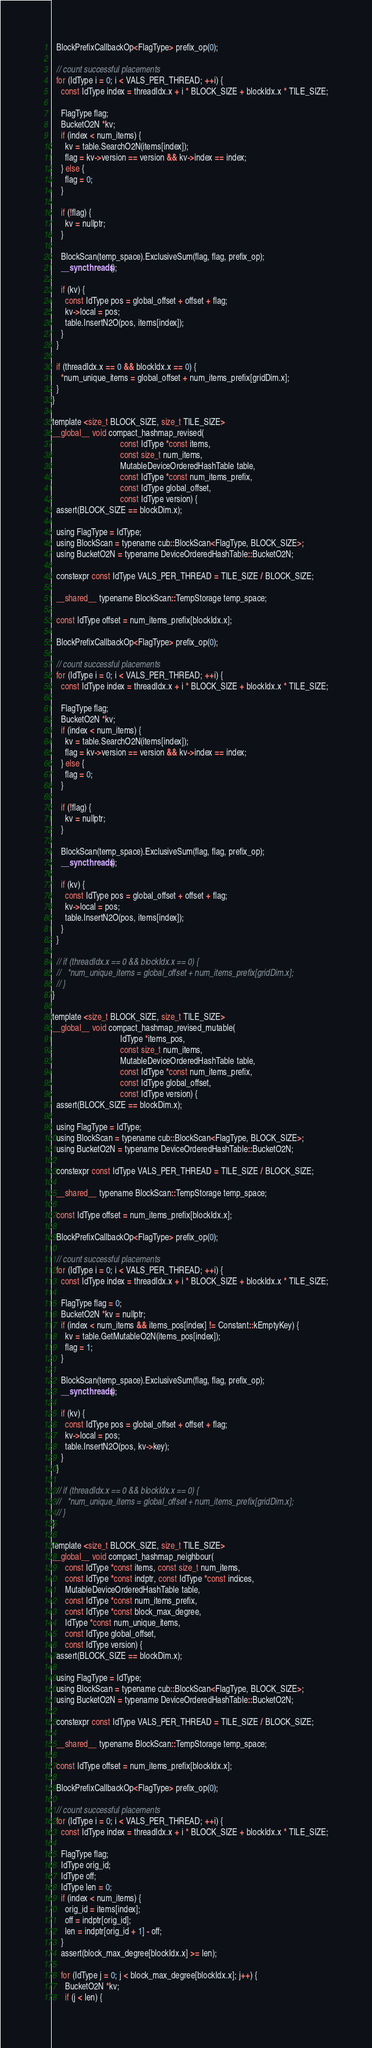<code> <loc_0><loc_0><loc_500><loc_500><_Cuda_>
  BlockPrefixCallbackOp<FlagType> prefix_op(0);

  // count successful placements
  for (IdType i = 0; i < VALS_PER_THREAD; ++i) {
    const IdType index = threadIdx.x + i * BLOCK_SIZE + blockIdx.x * TILE_SIZE;

    FlagType flag;
    BucketO2N *kv;
    if (index < num_items) {
      kv = table.SearchO2N(items[index]);
      flag = kv->version == version && kv->index == index;
    } else {
      flag = 0;
    }

    if (!flag) {
      kv = nullptr;
    }

    BlockScan(temp_space).ExclusiveSum(flag, flag, prefix_op);
    __syncthreads();

    if (kv) {
      const IdType pos = global_offset + offset + flag;
      kv->local = pos;
      table.InsertN2O(pos, items[index]);
    }
  }

  if (threadIdx.x == 0 && blockIdx.x == 0) {
    *num_unique_items = global_offset + num_items_prefix[gridDim.x];
  }
}

template <size_t BLOCK_SIZE, size_t TILE_SIZE>
__global__ void compact_hashmap_revised(
                                const IdType *const items,
                                const size_t num_items,
                                MutableDeviceOrderedHashTable table,
                                const IdType *const num_items_prefix,
                                const IdType global_offset,
                                const IdType version) {
  assert(BLOCK_SIZE == blockDim.x);

  using FlagType = IdType;
  using BlockScan = typename cub::BlockScan<FlagType, BLOCK_SIZE>;
  using BucketO2N = typename DeviceOrderedHashTable::BucketO2N;

  constexpr const IdType VALS_PER_THREAD = TILE_SIZE / BLOCK_SIZE;

  __shared__ typename BlockScan::TempStorage temp_space;

  const IdType offset = num_items_prefix[blockIdx.x];

  BlockPrefixCallbackOp<FlagType> prefix_op(0);

  // count successful placements
  for (IdType i = 0; i < VALS_PER_THREAD; ++i) {
    const IdType index = threadIdx.x + i * BLOCK_SIZE + blockIdx.x * TILE_SIZE;

    FlagType flag;
    BucketO2N *kv;
    if (index < num_items) {
      kv = table.SearchO2N(items[index]);
      flag = kv->version == version && kv->index == index;
    } else {
      flag = 0;
    }

    if (!flag) {
      kv = nullptr;
    }

    BlockScan(temp_space).ExclusiveSum(flag, flag, prefix_op);
    __syncthreads();

    if (kv) {
      const IdType pos = global_offset + offset + flag;
      kv->local = pos;
      table.InsertN2O(pos, items[index]);
    }
  }

  // if (threadIdx.x == 0 && blockIdx.x == 0) {
  //   *num_unique_items = global_offset + num_items_prefix[gridDim.x];
  // }
}

template <size_t BLOCK_SIZE, size_t TILE_SIZE>
__global__ void compact_hashmap_revised_mutable(
                                IdType *items_pos,
                                const size_t num_items,
                                MutableDeviceOrderedHashTable table,
                                const IdType *const num_items_prefix,
                                const IdType global_offset,
                                const IdType version) {
  assert(BLOCK_SIZE == blockDim.x);

  using FlagType = IdType;
  using BlockScan = typename cub::BlockScan<FlagType, BLOCK_SIZE>;
  using BucketO2N = typename DeviceOrderedHashTable::BucketO2N;

  constexpr const IdType VALS_PER_THREAD = TILE_SIZE / BLOCK_SIZE;

  __shared__ typename BlockScan::TempStorage temp_space;

  const IdType offset = num_items_prefix[blockIdx.x];

  BlockPrefixCallbackOp<FlagType> prefix_op(0);

  // count successful placements
  for (IdType i = 0; i < VALS_PER_THREAD; ++i) {
    const IdType index = threadIdx.x + i * BLOCK_SIZE + blockIdx.x * TILE_SIZE;

    FlagType flag = 0;
    BucketO2N *kv = nullptr;
    if (index < num_items && items_pos[index] != Constant::kEmptyKey) {
      kv = table.GetMutableO2N(items_pos[index]);
      flag = 1;
    }

    BlockScan(temp_space).ExclusiveSum(flag, flag, prefix_op);
    __syncthreads();

    if (kv) {
      const IdType pos = global_offset + offset + flag;
      kv->local = pos;
      table.InsertN2O(pos, kv->key);
    }
  }

  // if (threadIdx.x == 0 && blockIdx.x == 0) {
  //   *num_unique_items = global_offset + num_items_prefix[gridDim.x];
  // }
}

template <size_t BLOCK_SIZE, size_t TILE_SIZE>
__global__ void compact_hashmap_neighbour(
      const IdType *const items, const size_t num_items,
      const IdType *const indptr, const IdType *const indices,
      MutableDeviceOrderedHashTable table,
      const IdType *const num_items_prefix,
      const IdType *const block_max_degree,
      IdType *const num_unique_items,
      const IdType global_offset,
      const IdType version) {
  assert(BLOCK_SIZE == blockDim.x);

  using FlagType = IdType;
  using BlockScan = typename cub::BlockScan<FlagType, BLOCK_SIZE>;
  using BucketO2N = typename DeviceOrderedHashTable::BucketO2N;

  constexpr const IdType VALS_PER_THREAD = TILE_SIZE / BLOCK_SIZE;

  __shared__ typename BlockScan::TempStorage temp_space;

  const IdType offset = num_items_prefix[blockIdx.x];

  BlockPrefixCallbackOp<FlagType> prefix_op(0);

  // count successful placements
  for (IdType i = 0; i < VALS_PER_THREAD; ++i) {
    const IdType index = threadIdx.x + i * BLOCK_SIZE + blockIdx.x * TILE_SIZE;
    
    FlagType flag;
    IdType orig_id;
    IdType off;
    IdType len = 0;
    if (index < num_items) {
      orig_id = items[index];
      off = indptr[orig_id];
      len = indptr[orig_id + 1] - off;
    }
    assert(block_max_degree[blockIdx.x] >= len);

    for (IdType j = 0; j < block_max_degree[blockIdx.x]; j++) {
      BucketO2N *kv;
      if (j < len) {</code> 